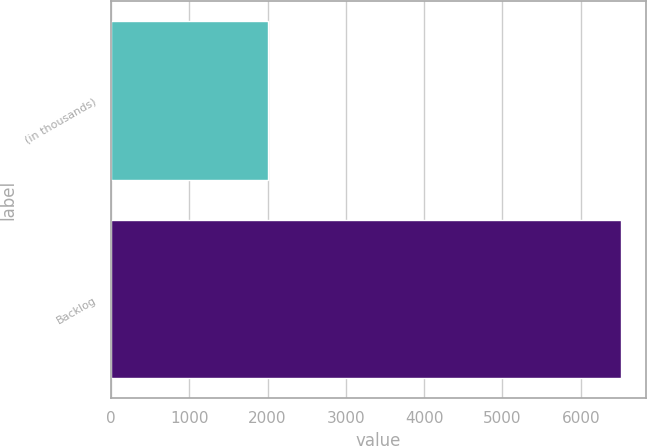Convert chart to OTSL. <chart><loc_0><loc_0><loc_500><loc_500><bar_chart><fcel>(in thousands)<fcel>Backlog<nl><fcel>2009<fcel>6514<nl></chart> 